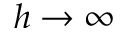Convert formula to latex. <formula><loc_0><loc_0><loc_500><loc_500>h \rightarrow \infty</formula> 